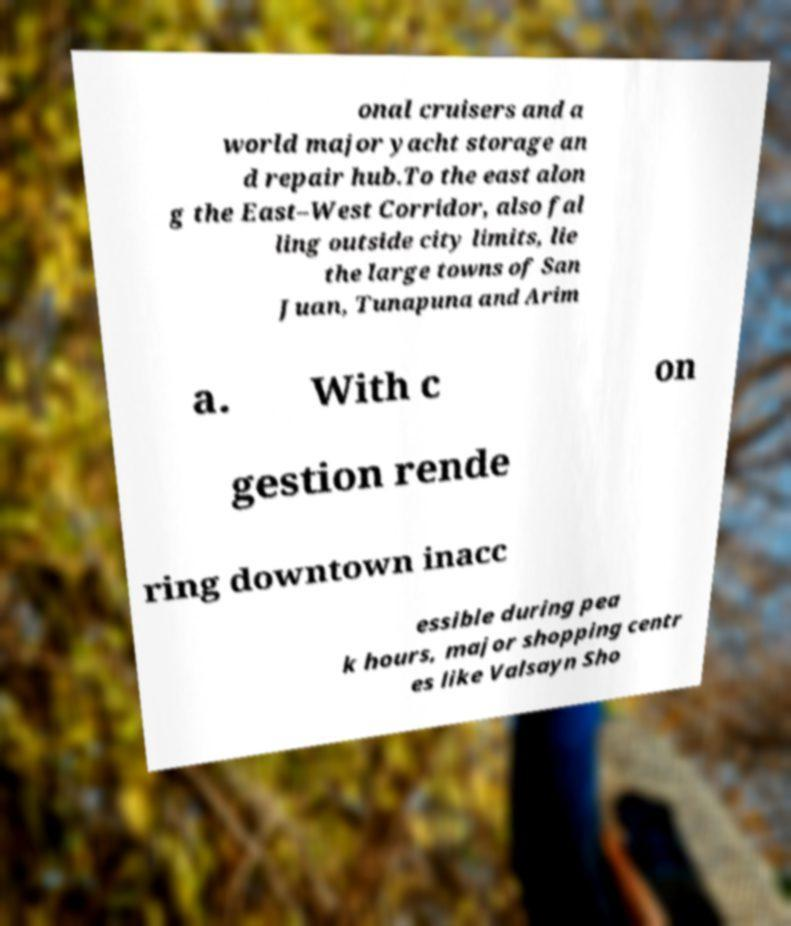Could you assist in decoding the text presented in this image and type it out clearly? onal cruisers and a world major yacht storage an d repair hub.To the east alon g the East–West Corridor, also fal ling outside city limits, lie the large towns of San Juan, Tunapuna and Arim a. With c on gestion rende ring downtown inacc essible during pea k hours, major shopping centr es like Valsayn Sho 